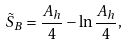<formula> <loc_0><loc_0><loc_500><loc_500>\tilde { S } _ { B } = \frac { A _ { h } } { 4 } - \ln \frac { A _ { h } } { 4 } ,</formula> 